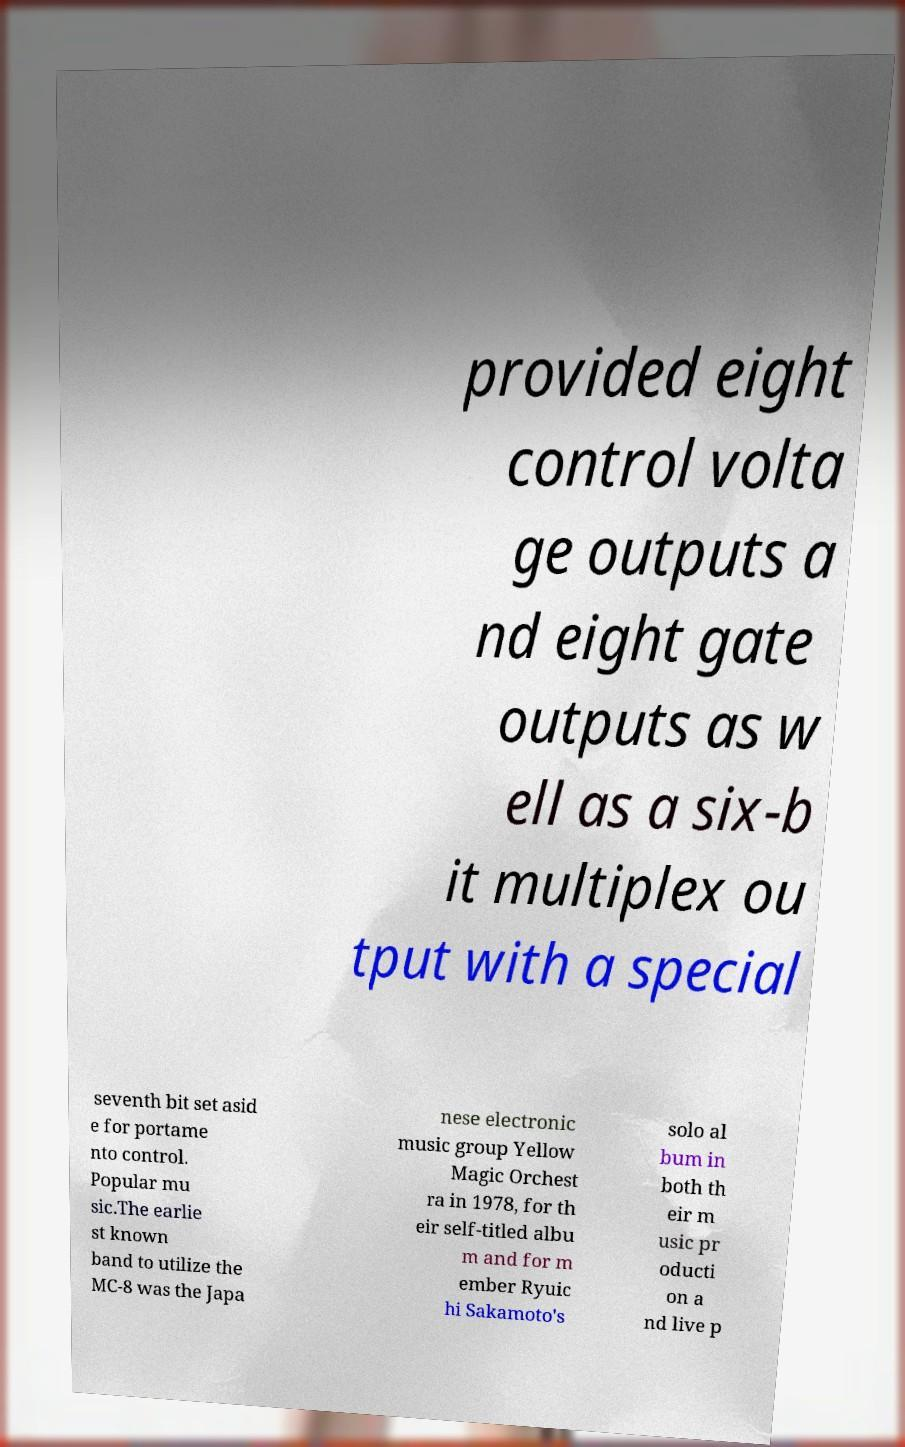I need the written content from this picture converted into text. Can you do that? provided eight control volta ge outputs a nd eight gate outputs as w ell as a six-b it multiplex ou tput with a special seventh bit set asid e for portame nto control. Popular mu sic.The earlie st known band to utilize the MC-8 was the Japa nese electronic music group Yellow Magic Orchest ra in 1978, for th eir self-titled albu m and for m ember Ryuic hi Sakamoto's solo al bum in both th eir m usic pr oducti on a nd live p 